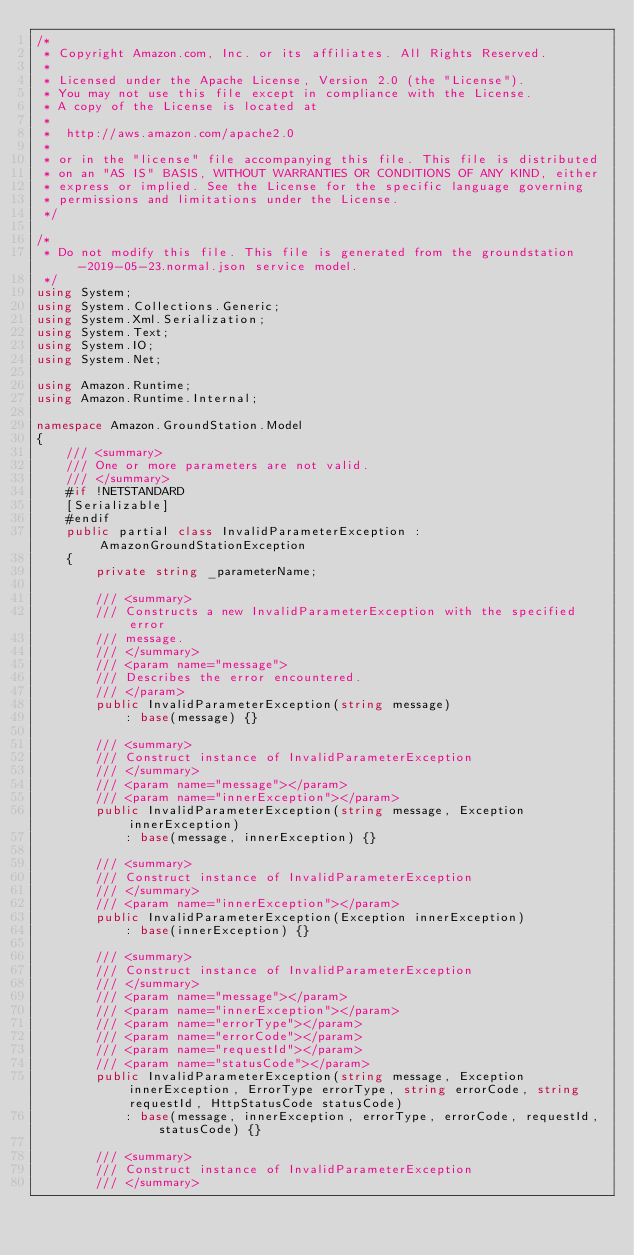Convert code to text. <code><loc_0><loc_0><loc_500><loc_500><_C#_>/*
 * Copyright Amazon.com, Inc. or its affiliates. All Rights Reserved.
 * 
 * Licensed under the Apache License, Version 2.0 (the "License").
 * You may not use this file except in compliance with the License.
 * A copy of the License is located at
 * 
 *  http://aws.amazon.com/apache2.0
 * 
 * or in the "license" file accompanying this file. This file is distributed
 * on an "AS IS" BASIS, WITHOUT WARRANTIES OR CONDITIONS OF ANY KIND, either
 * express or implied. See the License for the specific language governing
 * permissions and limitations under the License.
 */

/*
 * Do not modify this file. This file is generated from the groundstation-2019-05-23.normal.json service model.
 */
using System;
using System.Collections.Generic;
using System.Xml.Serialization;
using System.Text;
using System.IO;
using System.Net;

using Amazon.Runtime;
using Amazon.Runtime.Internal;

namespace Amazon.GroundStation.Model
{
    /// <summary>
    /// One or more parameters are not valid.
    /// </summary>
    #if !NETSTANDARD
    [Serializable]
    #endif
    public partial class InvalidParameterException : AmazonGroundStationException
    {
        private string _parameterName;

        /// <summary>
        /// Constructs a new InvalidParameterException with the specified error
        /// message.
        /// </summary>
        /// <param name="message">
        /// Describes the error encountered.
        /// </param>
        public InvalidParameterException(string message) 
            : base(message) {}

        /// <summary>
        /// Construct instance of InvalidParameterException
        /// </summary>
        /// <param name="message"></param>
        /// <param name="innerException"></param>
        public InvalidParameterException(string message, Exception innerException) 
            : base(message, innerException) {}

        /// <summary>
        /// Construct instance of InvalidParameterException
        /// </summary>
        /// <param name="innerException"></param>
        public InvalidParameterException(Exception innerException) 
            : base(innerException) {}

        /// <summary>
        /// Construct instance of InvalidParameterException
        /// </summary>
        /// <param name="message"></param>
        /// <param name="innerException"></param>
        /// <param name="errorType"></param>
        /// <param name="errorCode"></param>
        /// <param name="requestId"></param>
        /// <param name="statusCode"></param>
        public InvalidParameterException(string message, Exception innerException, ErrorType errorType, string errorCode, string requestId, HttpStatusCode statusCode) 
            : base(message, innerException, errorType, errorCode, requestId, statusCode) {}

        /// <summary>
        /// Construct instance of InvalidParameterException
        /// </summary></code> 